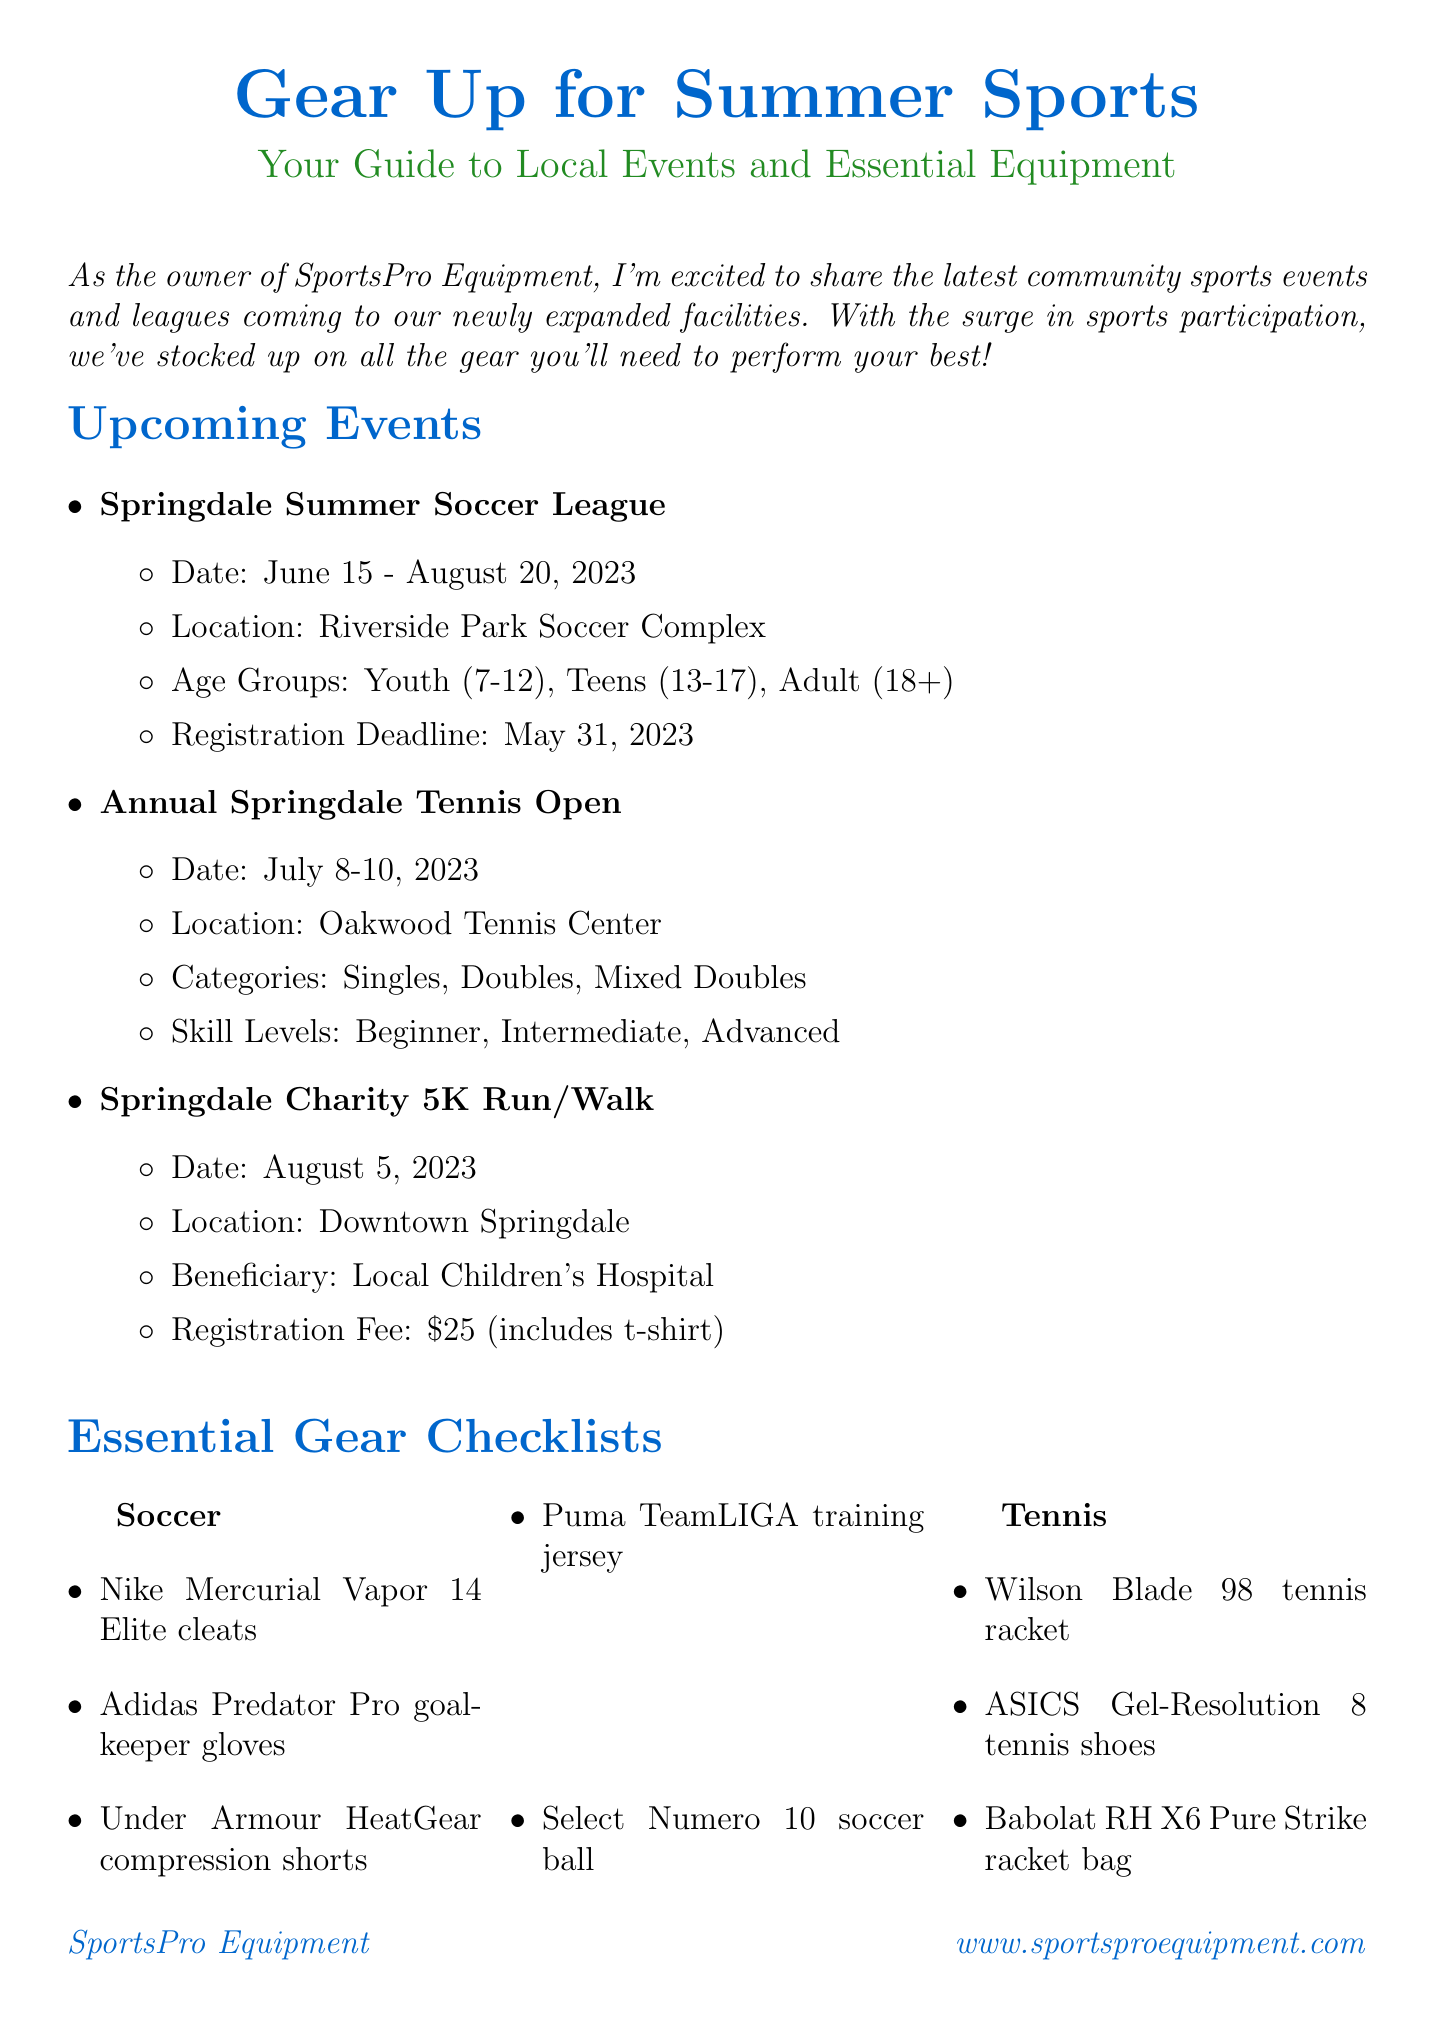What is the title of the newsletter? The title of the newsletter is stated at the beginning, introducing the theme of the document.
Answer: Gear Up for Summer Sports: Your Guide to Local Events and Essential Equipment When is the registration deadline for the Springdale Summer Soccer League? The registration deadline is specifically mentioned in the details of the soccer league event.
Answer: May 31, 2023 What is the date of the Annual Springdale Tennis Open? The dates for the tennis open are listed under the event details for the tournament.
Answer: July 8-10, 2023 How much is the registration fee for the Springdale Charity 5K Run/Walk? The registration fee is provided as part of the event description for the 5K run/walk.
Answer: $25 Which store offers a special discount for event registrations? The special offer is indicated to be available at the store mentioned throughout the newsletter.
Answer: SportsPro Equipment What item is listed under essential gear for soccer? The items for soccer are outlined in the checklist; one example is requested here.
Answer: Nike Mercurial Vapor 14 Elite cleats How long is the special offer valid? The duration of the special offer is specified in the section detailing the promotion.
Answer: Until August 31, 2023 What is the location for the Springdale Charity 5K Run/Walk? The location of this event is clearly detailed within the event information section.
Answer: Downtown Springdale 